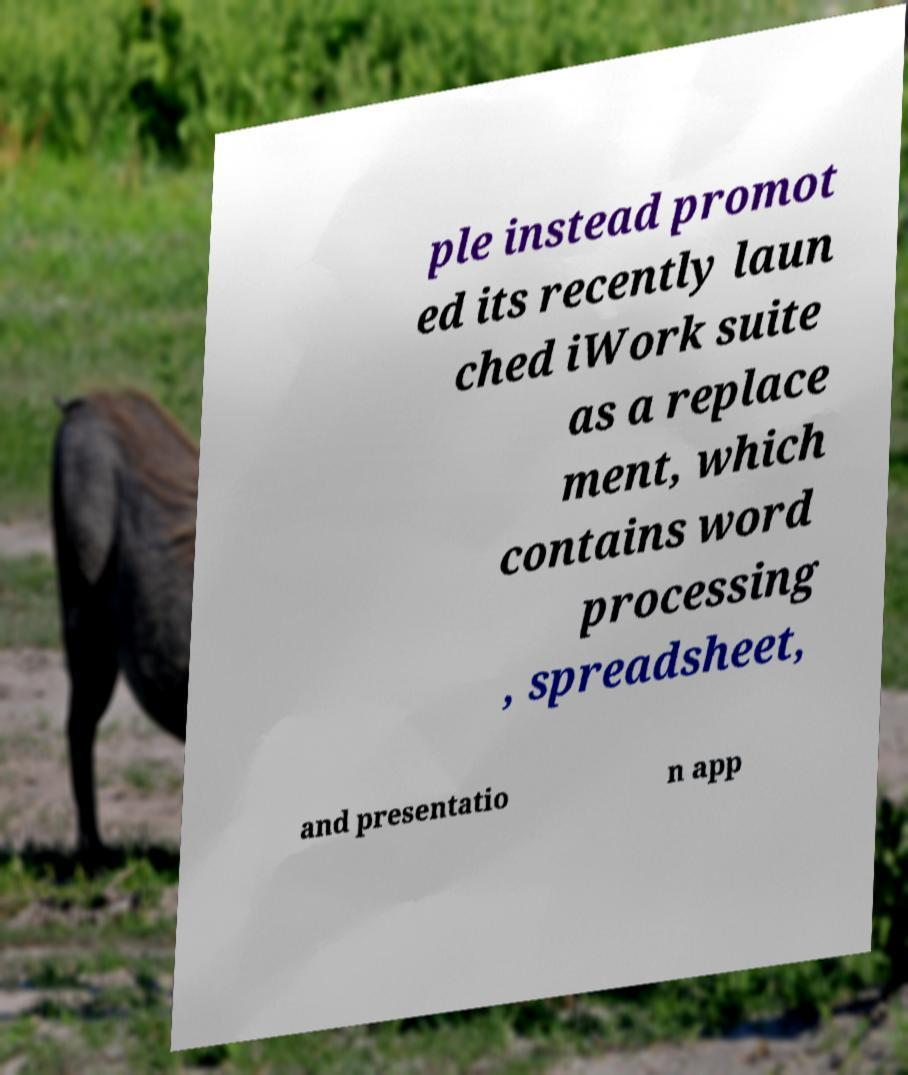Please read and relay the text visible in this image. What does it say? ple instead promot ed its recently laun ched iWork suite as a replace ment, which contains word processing , spreadsheet, and presentatio n app 